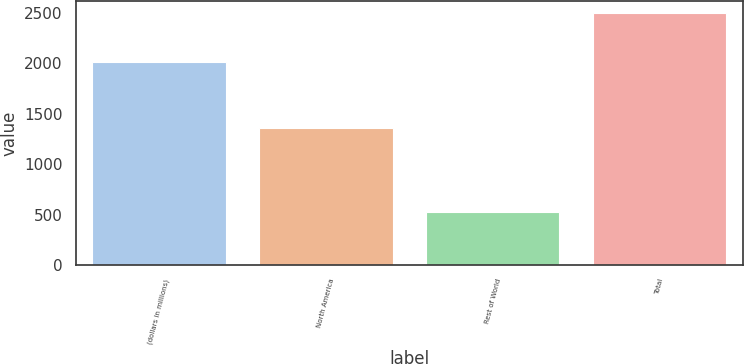Convert chart. <chart><loc_0><loc_0><loc_500><loc_500><bar_chart><fcel>(dollars in millions)<fcel>North America<fcel>Rest of World<fcel>Total<nl><fcel>2014<fcel>1358.5<fcel>523.8<fcel>2498.1<nl></chart> 